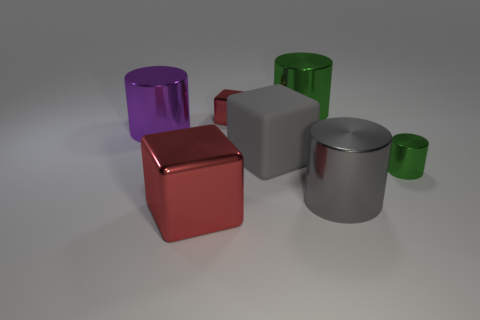Are there any other things that have the same material as the gray block?
Provide a short and direct response. No. How many spheres are either big metallic things or purple metallic objects?
Provide a short and direct response. 0. Are there any other things that have the same size as the gray matte object?
Your answer should be very brief. Yes. There is a green shiny cylinder on the right side of the big metallic cylinder behind the purple thing; what number of small green metallic cylinders are to the right of it?
Ensure brevity in your answer.  0. Does the large green object have the same shape as the big matte thing?
Ensure brevity in your answer.  No. Is the material of the green object that is in front of the big green shiny thing the same as the big cylinder on the left side of the large green cylinder?
Make the answer very short. Yes. How many objects are either green cylinders left of the small green cylinder or big cylinders that are in front of the large green thing?
Your answer should be very brief. 3. Is there any other thing that has the same shape as the gray metallic object?
Your answer should be very brief. Yes. What number of cyan matte blocks are there?
Keep it short and to the point. 0. Is there a brown metal thing that has the same size as the purple cylinder?
Provide a short and direct response. No. 